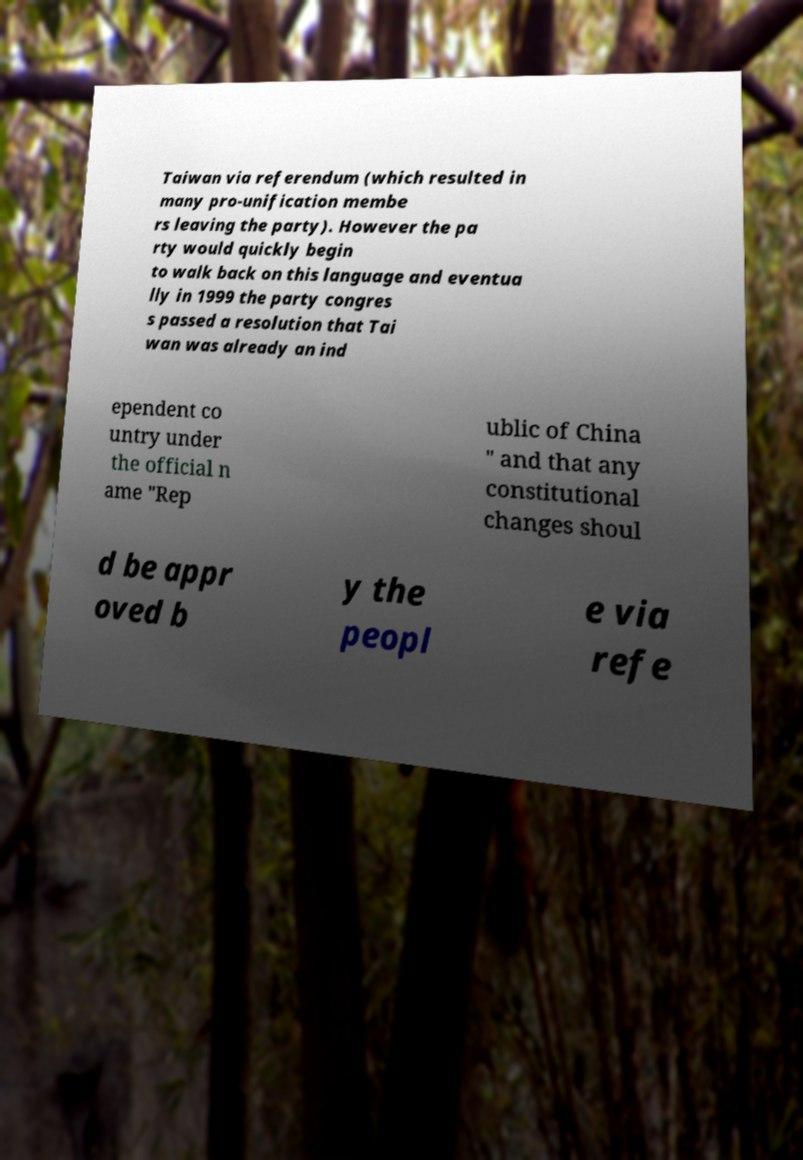For documentation purposes, I need the text within this image transcribed. Could you provide that? Taiwan via referendum (which resulted in many pro-unification membe rs leaving the party). However the pa rty would quickly begin to walk back on this language and eventua lly in 1999 the party congres s passed a resolution that Tai wan was already an ind ependent co untry under the official n ame "Rep ublic of China " and that any constitutional changes shoul d be appr oved b y the peopl e via refe 